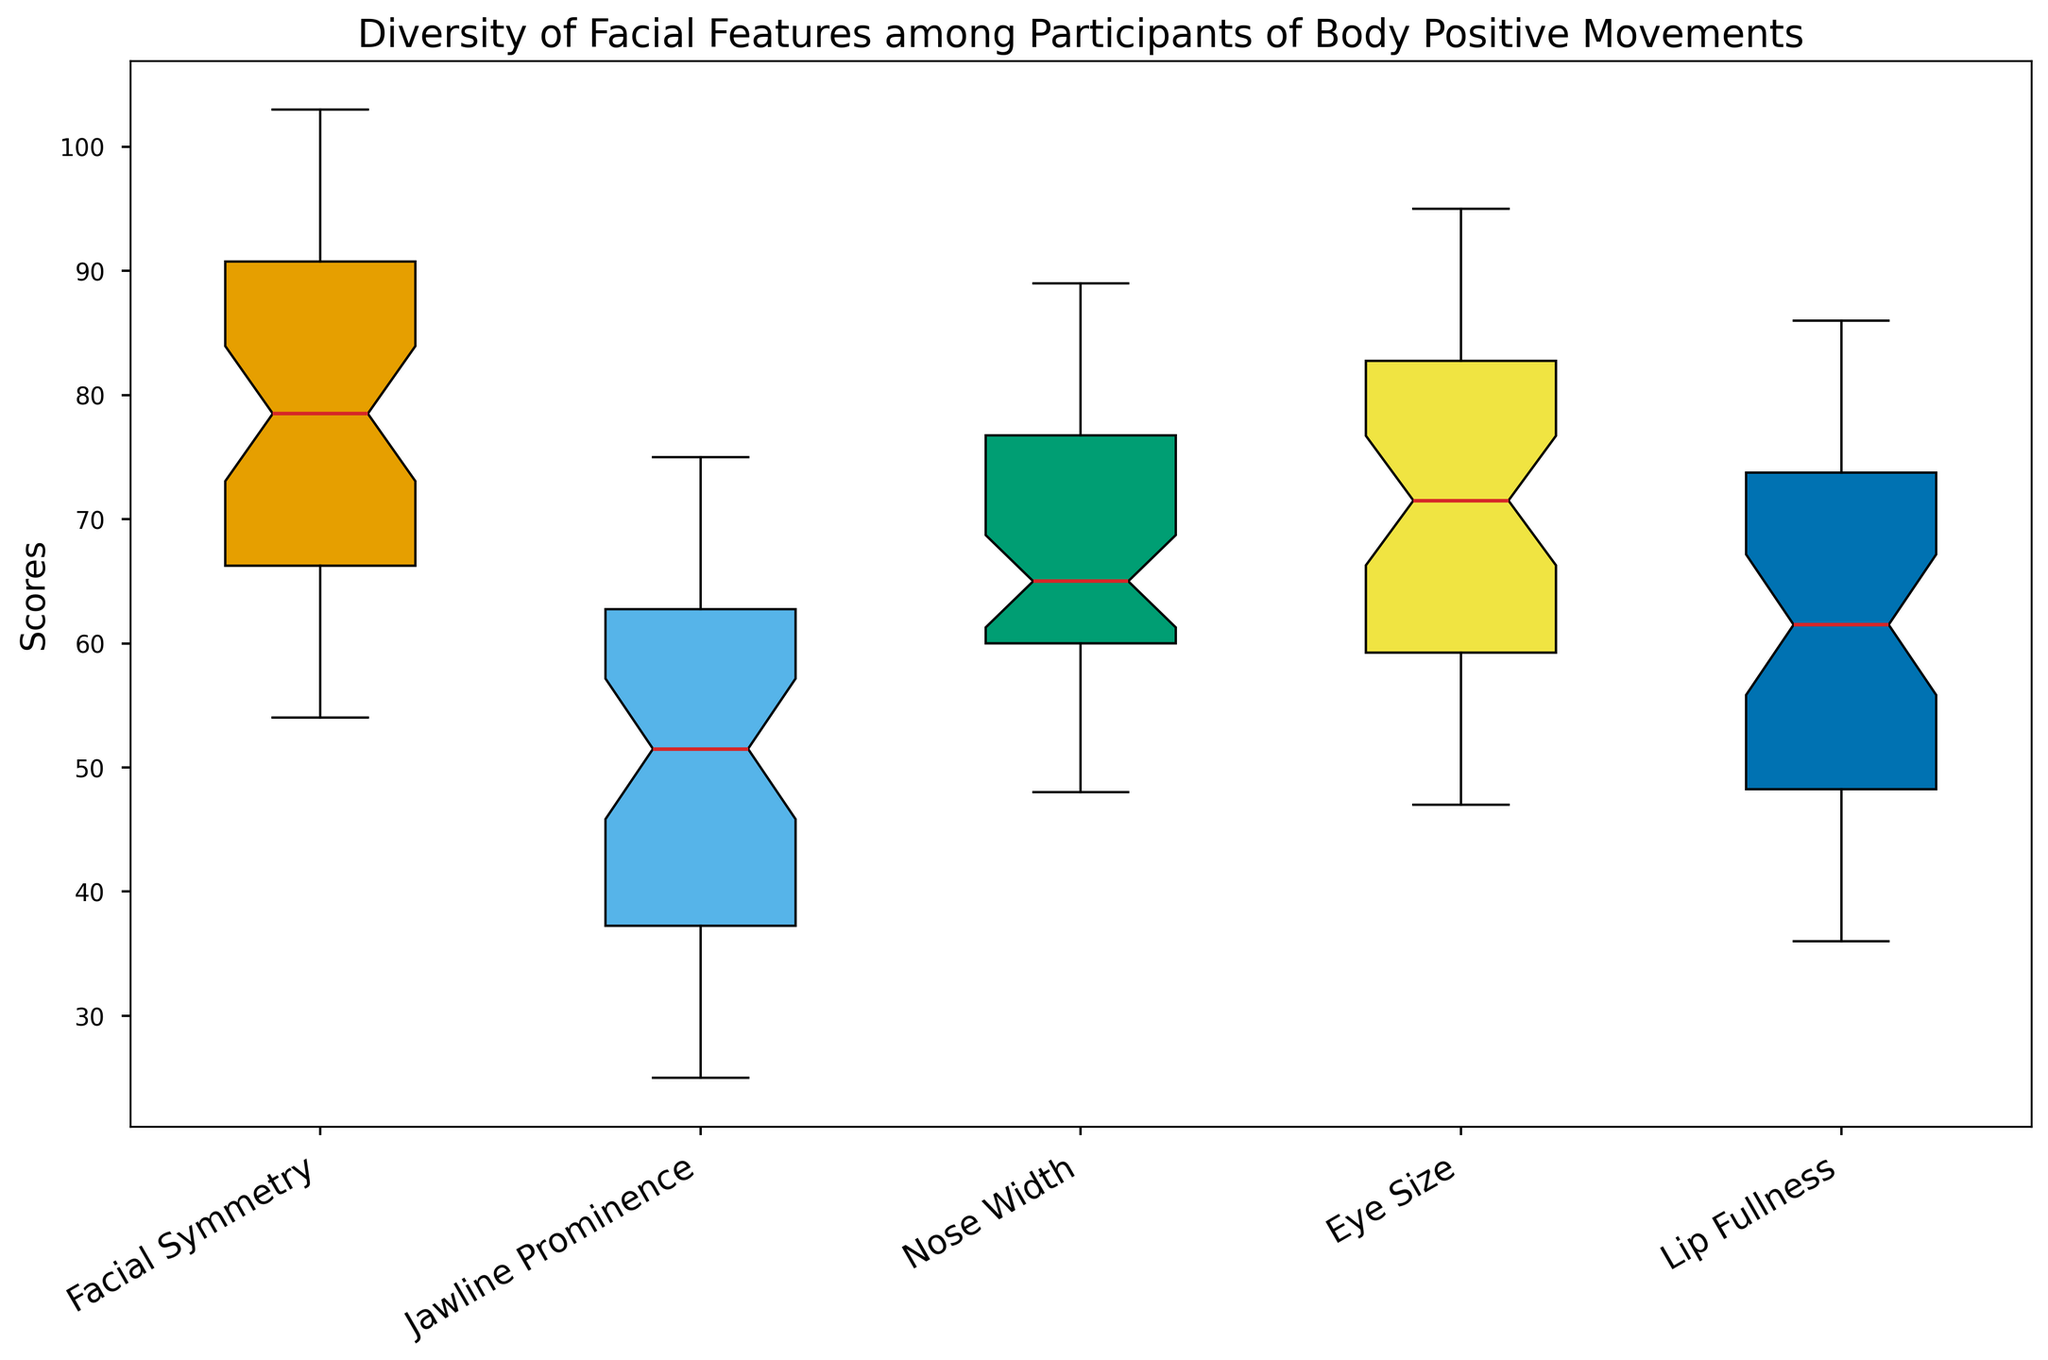What is the median value for Facial Symmetry? Locate the box plot for Facial Symmetry, find the line inside the box which represents the median.
Answer: 83 Which feature has the smallest range of values? The range is the difference between the maximum and minimum values. Nose Width has the smallest box height, indicating the smallest range.
Answer: Nose Width Which feature shows the highest median value? Compare the median lines (horizontal lines within the boxes) across all box plots. Facial Symmetry has the highest median.
Answer: Facial Symmetry What is the median value for Eye Size? Find the Eye Size box plot and identify the median line within the box.
Answer: 72 How do the interquartile ranges (IQR) of Facial Symmetry and Jawline Prominence compare? The IQR is the height of the box, from the lower quartile to the upper quartile. Compare the heights of the boxes for Facial Symmetry and Jawline Prominence.
Answer: Facial Symmetry has a larger IQR than Jawline Prominence Which feature has the largest variability? Variability can be inferred by the height of the box (interquartile range) and the length of the whiskers. Facial Symmetry has the largest variability as its box and whiskers are the longest.
Answer: Facial Symmetry How many features have median values greater than 65? Examine the median lines in each box plot to count those above the score of 65. Both Facial Symmetry and Eye Size have medians above 65.
Answer: 2 Is the median value of Lip Fullness higher or lower than that of Jawline Prominence? Compare the median lines of the Lip Fullness and Jawline Prominence box plots.
Answer: Higher What can be inferred about the outliers for Jawline Prominence compared to the other features? Examine the points outside the whiskers for each box plot, particularly for Jawline Prominence.
Answer: Jawline Prominence has more outliers and they are lower than the other features Describe the color used to represent the box plot for Nose Width. Examine the color fill of the Nose Width box plot.
Answer: Green 